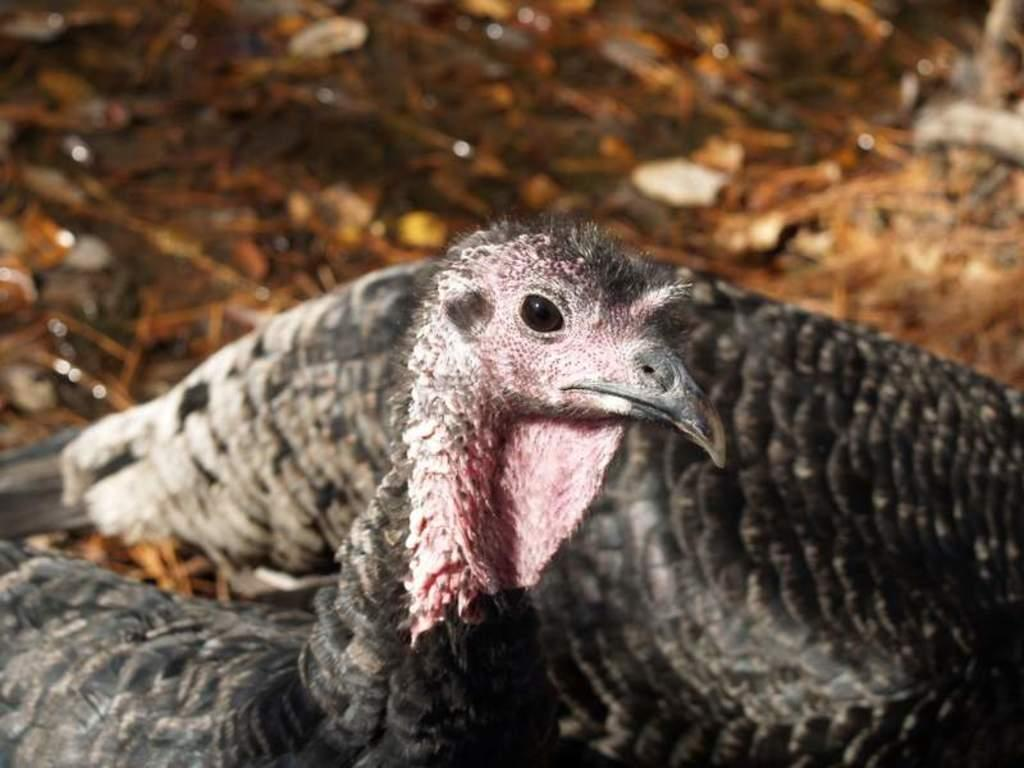What type of animals can be seen in the image? There are birds in the image. Can you describe the background of the image? The background of the image is blurry. What type of wave can be seen in the image? There is no wave present in the image; it features birds and a blurry background. How many ladybugs are visible in the image? There are no ladybugs present in the image. 